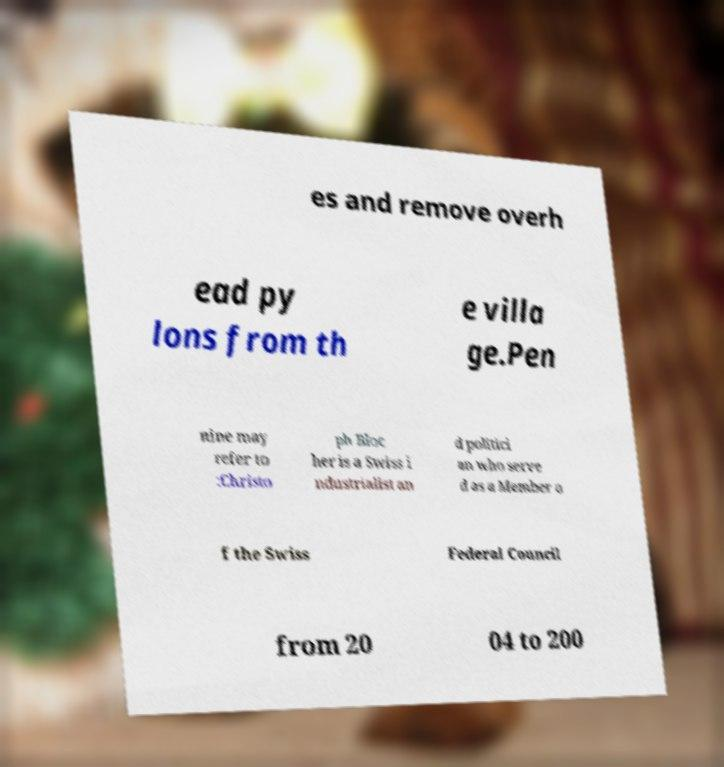Please identify and transcribe the text found in this image. es and remove overh ead py lons from th e villa ge.Pen nine may refer to :Christo ph Bloc her is a Swiss i ndustrialist an d politici an who serve d as a Member o f the Swiss Federal Council from 20 04 to 200 